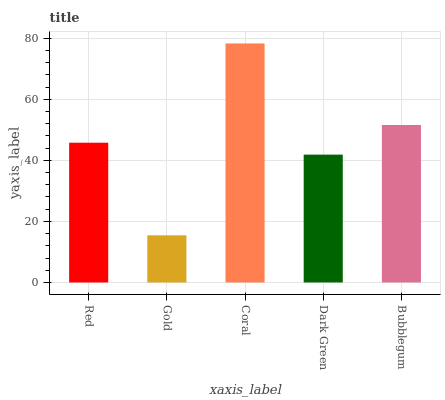Is Gold the minimum?
Answer yes or no. Yes. Is Coral the maximum?
Answer yes or no. Yes. Is Coral the minimum?
Answer yes or no. No. Is Gold the maximum?
Answer yes or no. No. Is Coral greater than Gold?
Answer yes or no. Yes. Is Gold less than Coral?
Answer yes or no. Yes. Is Gold greater than Coral?
Answer yes or no. No. Is Coral less than Gold?
Answer yes or no. No. Is Red the high median?
Answer yes or no. Yes. Is Red the low median?
Answer yes or no. Yes. Is Coral the high median?
Answer yes or no. No. Is Gold the low median?
Answer yes or no. No. 